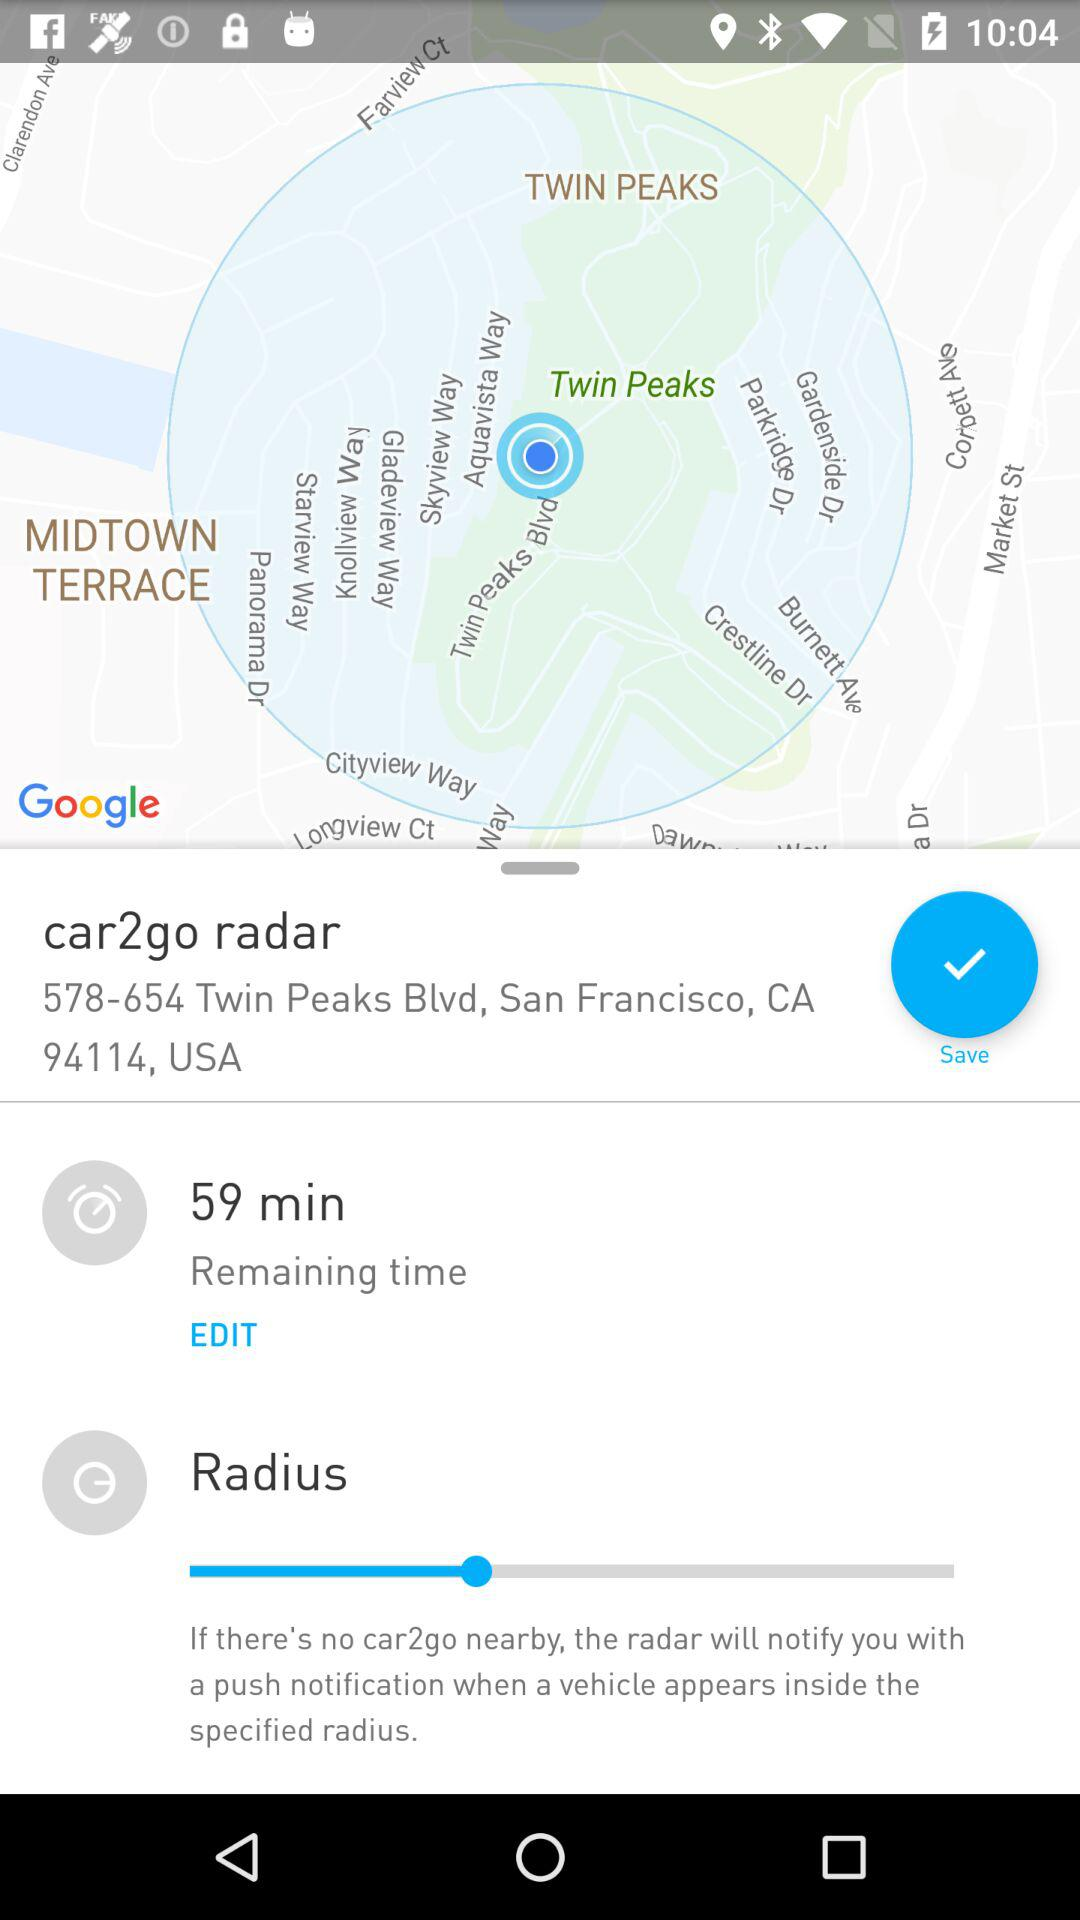What is the remaining time? The remaining time is 59 minutes. 